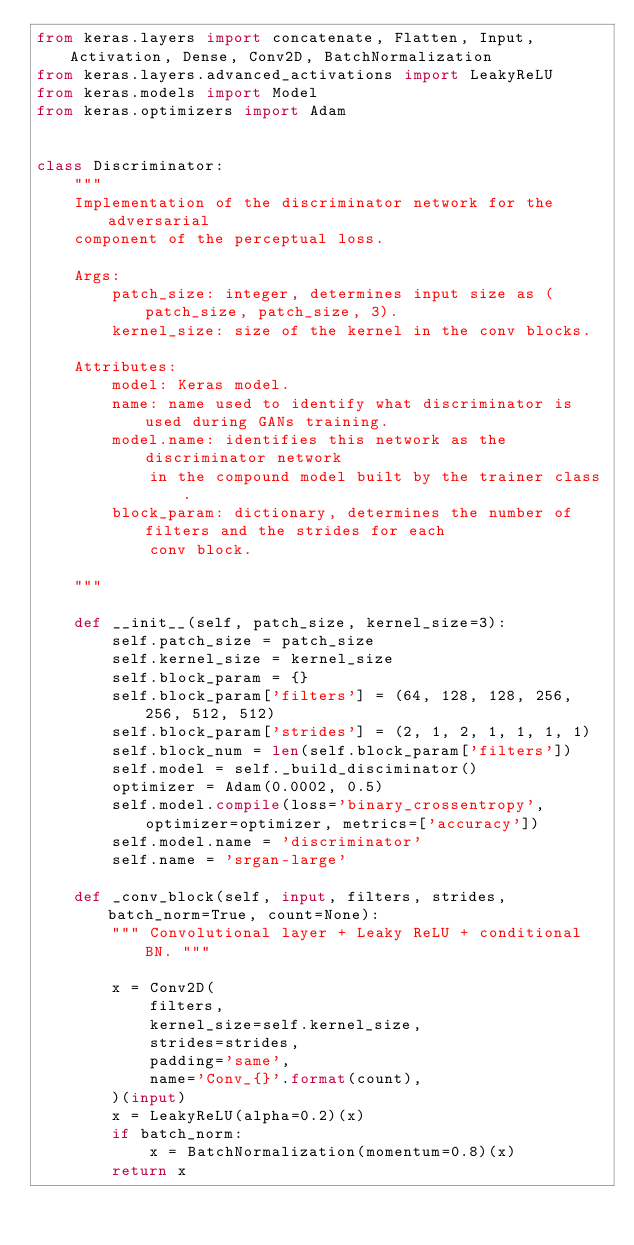<code> <loc_0><loc_0><loc_500><loc_500><_Python_>from keras.layers import concatenate, Flatten, Input, Activation, Dense, Conv2D, BatchNormalization
from keras.layers.advanced_activations import LeakyReLU
from keras.models import Model
from keras.optimizers import Adam


class Discriminator:
    """
    Implementation of the discriminator network for the adversarial
    component of the perceptual loss.

    Args:
        patch_size: integer, determines input size as (patch_size, patch_size, 3).
        kernel_size: size of the kernel in the conv blocks.

    Attributes:
        model: Keras model.
        name: name used to identify what discriminator is used during GANs training.
        model.name: identifies this network as the discriminator network
            in the compound model built by the trainer class.
        block_param: dictionary, determines the number of filters and the strides for each
            conv block.

    """

    def __init__(self, patch_size, kernel_size=3):
        self.patch_size = patch_size
        self.kernel_size = kernel_size
        self.block_param = {}
        self.block_param['filters'] = (64, 128, 128, 256, 256, 512, 512)
        self.block_param['strides'] = (2, 1, 2, 1, 1, 1, 1)
        self.block_num = len(self.block_param['filters'])
        self.model = self._build_disciminator()
        optimizer = Adam(0.0002, 0.5)
        self.model.compile(loss='binary_crossentropy', optimizer=optimizer, metrics=['accuracy'])
        self.model.name = 'discriminator'
        self.name = 'srgan-large'

    def _conv_block(self, input, filters, strides, batch_norm=True, count=None):
        """ Convolutional layer + Leaky ReLU + conditional BN. """

        x = Conv2D(
            filters,
            kernel_size=self.kernel_size,
            strides=strides,
            padding='same',
            name='Conv_{}'.format(count),
        )(input)
        x = LeakyReLU(alpha=0.2)(x)
        if batch_norm:
            x = BatchNormalization(momentum=0.8)(x)
        return x
</code> 